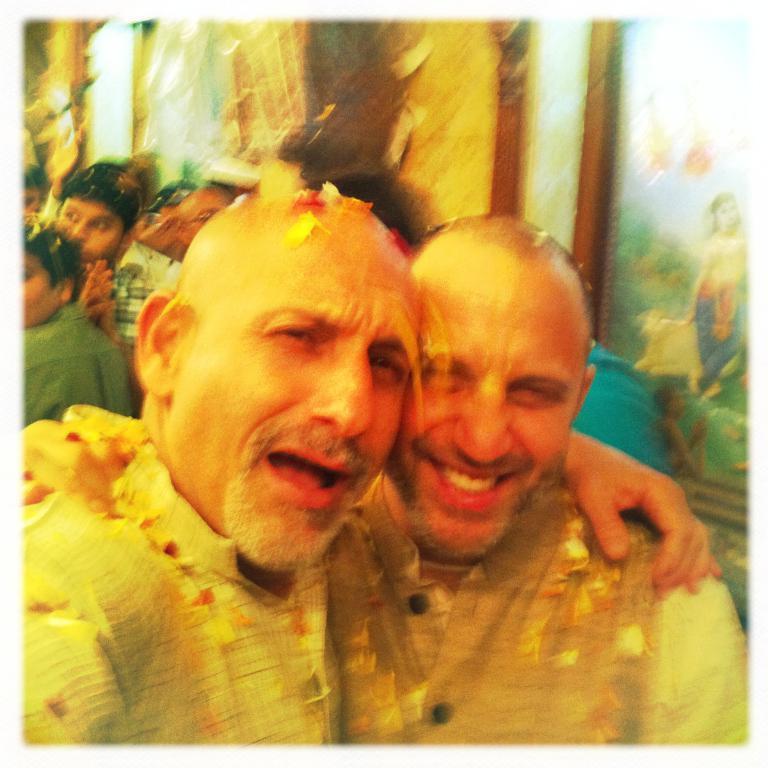Please provide a concise description of this image. In the center of the image we can see two persons are smiling and they are in different costumes. In the background there is a wall, one photo frame, few people are sitting and a few other objects. 